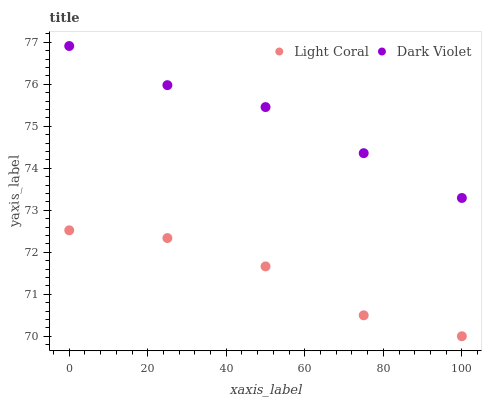Does Light Coral have the minimum area under the curve?
Answer yes or no. Yes. Does Dark Violet have the maximum area under the curve?
Answer yes or no. Yes. Does Dark Violet have the minimum area under the curve?
Answer yes or no. No. Is Dark Violet the smoothest?
Answer yes or no. Yes. Is Light Coral the roughest?
Answer yes or no. Yes. Is Dark Violet the roughest?
Answer yes or no. No. Does Light Coral have the lowest value?
Answer yes or no. Yes. Does Dark Violet have the lowest value?
Answer yes or no. No. Does Dark Violet have the highest value?
Answer yes or no. Yes. Is Light Coral less than Dark Violet?
Answer yes or no. Yes. Is Dark Violet greater than Light Coral?
Answer yes or no. Yes. Does Light Coral intersect Dark Violet?
Answer yes or no. No. 